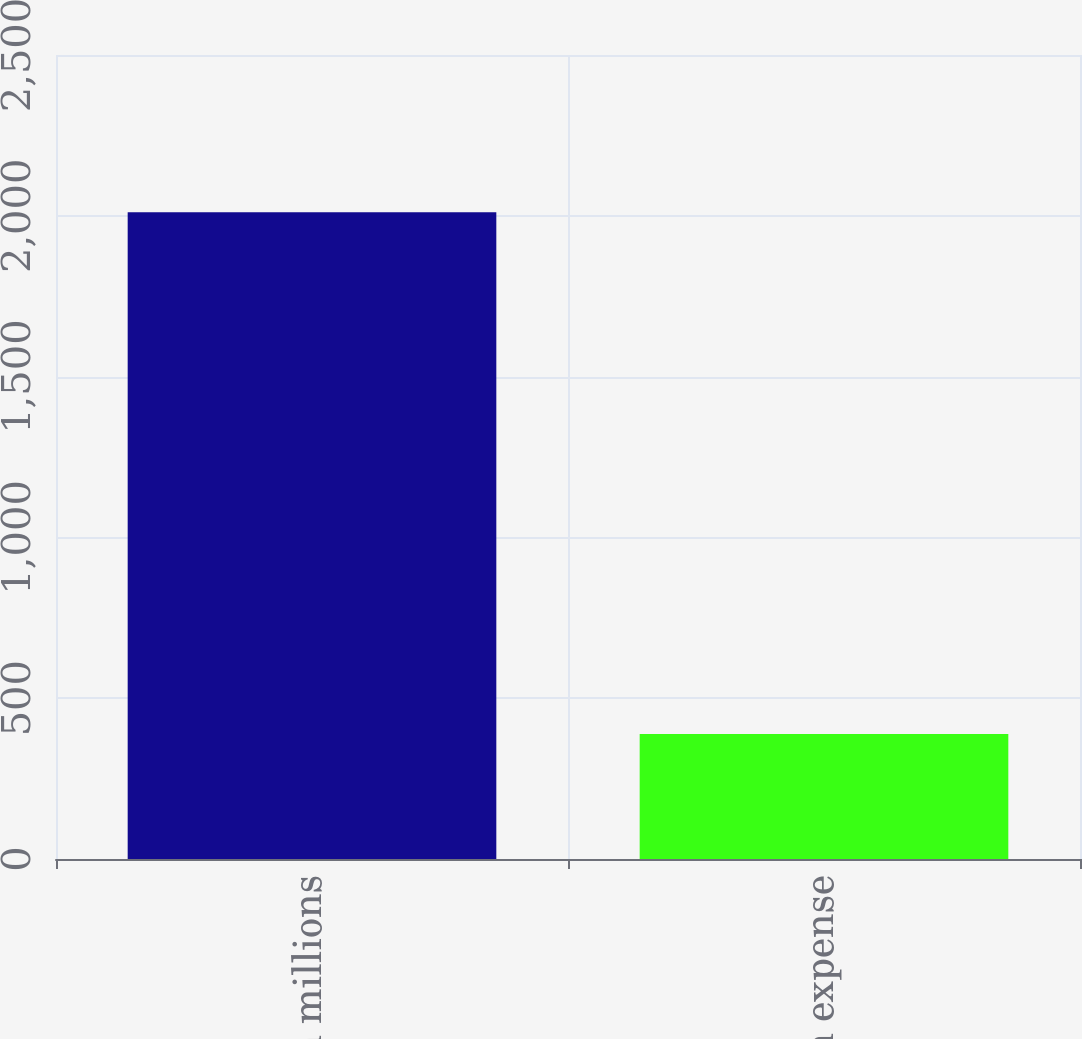Convert chart to OTSL. <chart><loc_0><loc_0><loc_500><loc_500><bar_chart><fcel>in millions<fcel>Amortization expense<nl><fcel>2011<fcel>389<nl></chart> 